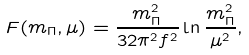<formula> <loc_0><loc_0><loc_500><loc_500>F ( m _ { \Pi } , \mu ) = \frac { m _ { \Pi } ^ { 2 } } { 3 2 \pi ^ { 2 } f ^ { 2 } } \ln { \frac { m _ { \Pi } ^ { 2 } } { \mu ^ { 2 } } } ,</formula> 